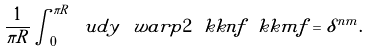Convert formula to latex. <formula><loc_0><loc_0><loc_500><loc_500>\frac { 1 } { \pi R } \int _ { 0 } ^ { \pi R } \ u d y \, \ w a r p { 2 } \ k k n { f } \ k k m { f } = \delta ^ { n m } .</formula> 